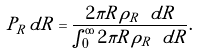<formula> <loc_0><loc_0><loc_500><loc_500>P _ { R } \, d R = \frac { 2 \pi R \, \rho _ { R } \ d R } { \int _ { 0 } ^ { \infty } 2 \pi R \, \rho _ { R } \ d R } .</formula> 